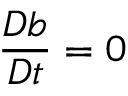Convert formula to latex. <formula><loc_0><loc_0><loc_500><loc_500>\frac { D b } { D t } = 0</formula> 